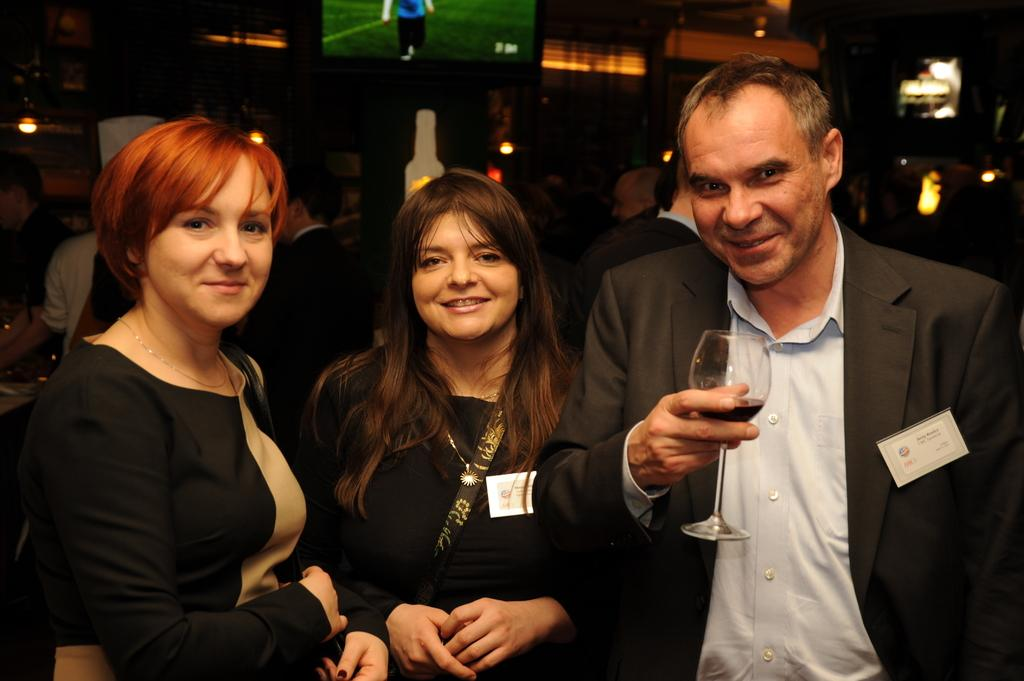How many people are in the foreground of the image? There are two women and a man in the image. What is the man holding in the image? The man is holding a glass. What is the facial expression of the people in the image? The people in the image have smiles on their faces. Can you describe the people visible in the background of the image? There are more people visible in the background of the image, but their specific details are not clear from the provided facts. What type of dogs are running alongside the cart in the image? There are no dogs or carts present in the image. 